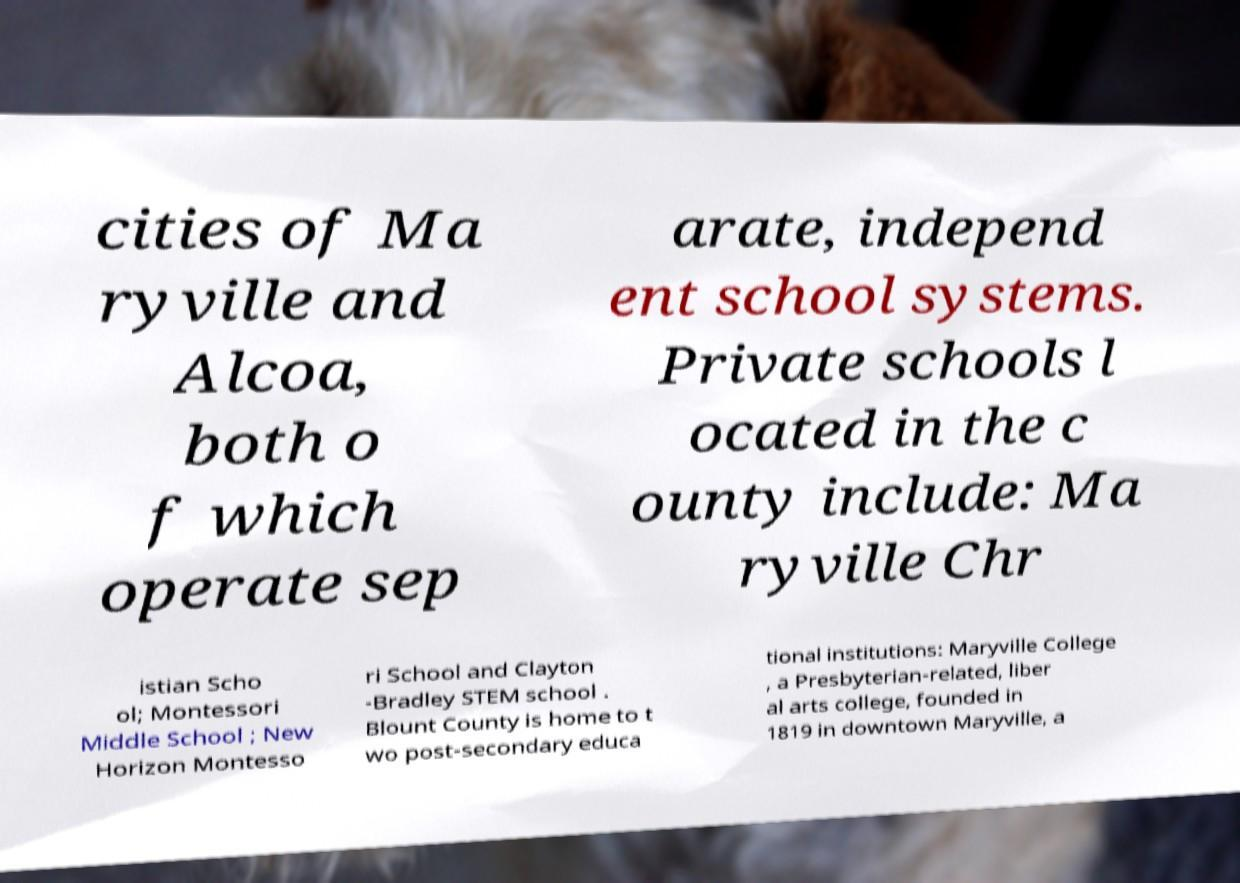For documentation purposes, I need the text within this image transcribed. Could you provide that? cities of Ma ryville and Alcoa, both o f which operate sep arate, independ ent school systems. Private schools l ocated in the c ounty include: Ma ryville Chr istian Scho ol; Montessori Middle School ; New Horizon Montesso ri School and Clayton -Bradley STEM school . Blount County is home to t wo post-secondary educa tional institutions: Maryville College , a Presbyterian-related, liber al arts college, founded in 1819 in downtown Maryville, a 